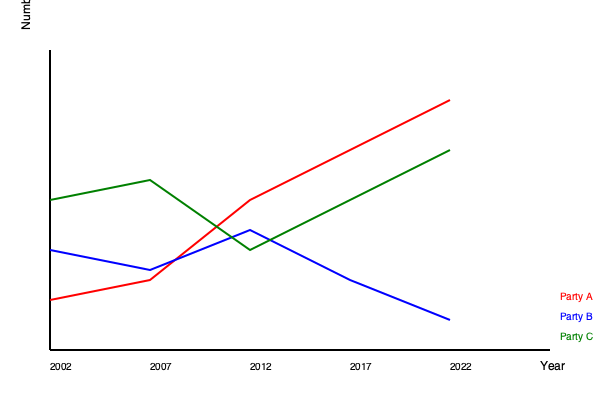Based on the line graph showing the number of seats won by major political parties in Mumbai's municipal elections from 2002 to 2022, which party has shown the most consistent upward trend in seat gains, and what might this suggest about the changing political landscape in Mumbai? To answer this question, we need to analyze the trends for each party:

1. Party A (red line):
   - Started with the highest number of seats in 2002
   - Shows a consistent downward trend from 2002 to 2022
   - Lost the most seats over the 20-year period

2. Party B (blue line):
   - Started with the second-highest number of seats in 2002
   - Shows fluctuations but an overall upward trend
   - Ended with the highest number of seats in 2022

3. Party C (green line):
   - Started with the lowest number of seats in 2002
   - Shows fluctuations but a general upward trend
   - Ended with more seats than it started with, but still fewer than Party B

Party B shows the most consistent upward trend, despite some fluctuations. This suggests:

1. Increasing popularity of Party B's policies or candidates
2. A shift in voter preferences towards Party B's ideology
3. Possible decline in the effectiveness of Party A's strategies
4. Changing demographics or socio-economic factors in Mumbai favoring Party B

This trend indicates a significant shift in Mumbai's political landscape, with Party B gaining ground and potentially becoming the dominant force in local politics. It also suggests that the issues and priorities of Mumbai's voters may have evolved over the past two decades, leading to this change in political representation.
Answer: Party B; indicates shifting voter preferences and changing political dynamics in Mumbai. 